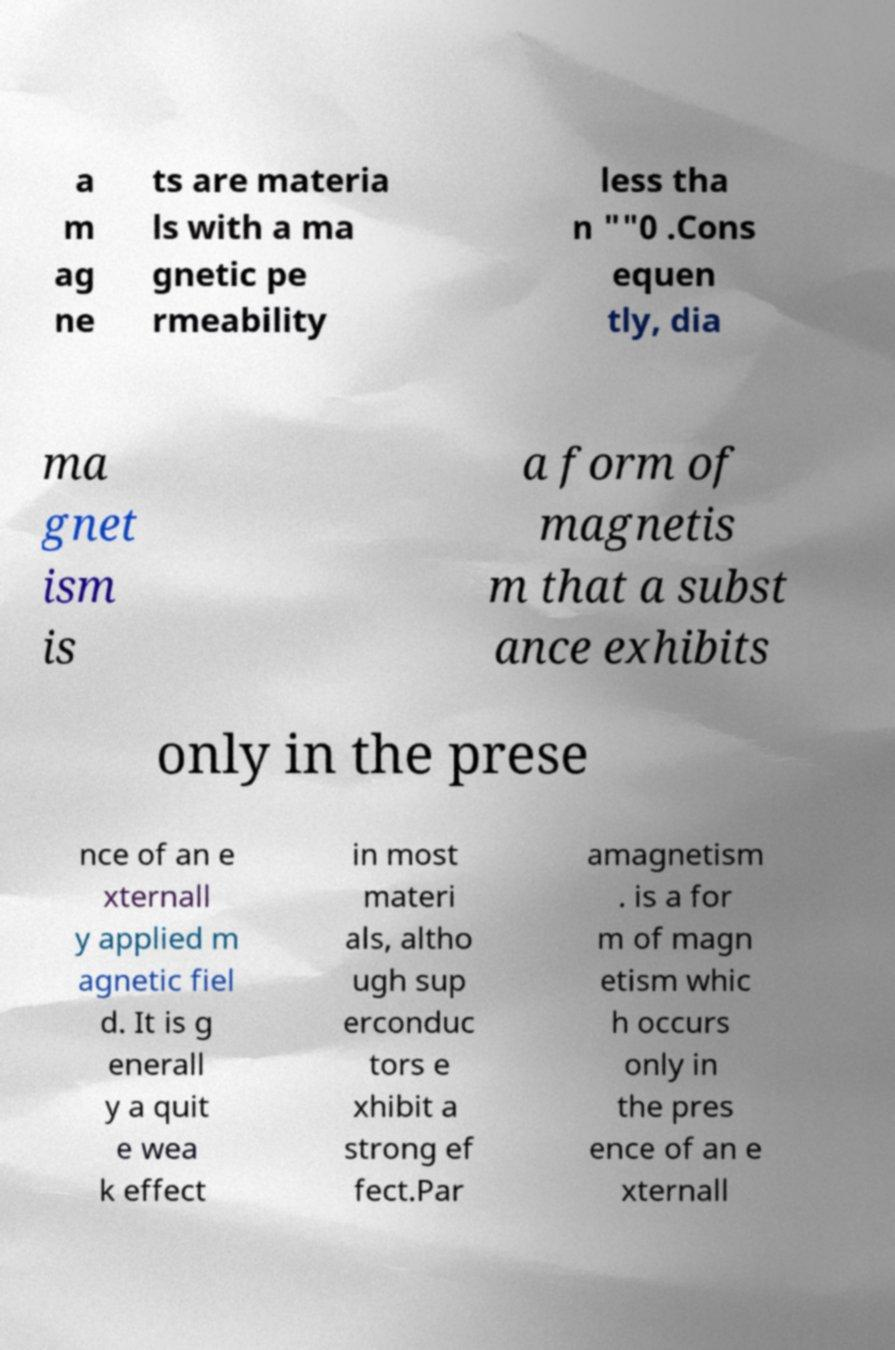Can you accurately transcribe the text from the provided image for me? a m ag ne ts are materia ls with a ma gnetic pe rmeability less tha n ""0 .Cons equen tly, dia ma gnet ism is a form of magnetis m that a subst ance exhibits only in the prese nce of an e xternall y applied m agnetic fiel d. It is g enerall y a quit e wea k effect in most materi als, altho ugh sup erconduc tors e xhibit a strong ef fect.Par amagnetism . is a for m of magn etism whic h occurs only in the pres ence of an e xternall 